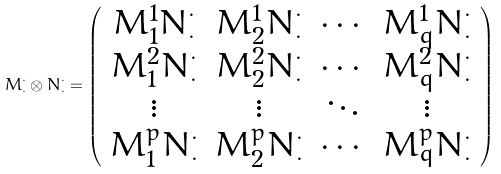Convert formula to latex. <formula><loc_0><loc_0><loc_500><loc_500>M ^ { \cdot } _ { \cdot } \otimes N ^ { \cdot } _ { \cdot } = \left ( \begin{array} { c c c c } M ^ { 1 } _ { 1 } N ^ { \cdot } _ { \cdot } & M ^ { 1 } _ { 2 } N ^ { \cdot } _ { \cdot } & \cdots & M ^ { 1 } _ { q } N ^ { \cdot } _ { \cdot } \\ M ^ { 2 } _ { 1 } N ^ { \cdot } _ { \cdot } & M ^ { 2 } _ { 2 } N ^ { \cdot } _ { \cdot } & \cdots & M ^ { 2 } _ { q } N ^ { \cdot } _ { \cdot } \\ \vdots & \vdots & \ddots & \vdots \\ M ^ { p } _ { 1 } N ^ { \cdot } _ { \cdot } & M ^ { p } _ { 2 } N ^ { \cdot } _ { \cdot } & \cdots & M ^ { p } _ { q } N ^ { \cdot } _ { \cdot } \end{array} \right )</formula> 